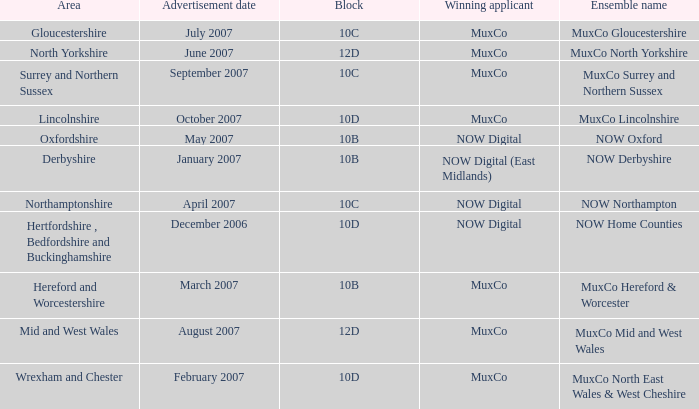Which Block does Northamptonshire Area have? 10C. Give me the full table as a dictionary. {'header': ['Area', 'Advertisement date', 'Block', 'Winning applicant', 'Ensemble name'], 'rows': [['Gloucestershire', 'July 2007', '10C', 'MuxCo', 'MuxCo Gloucestershire'], ['North Yorkshire', 'June 2007', '12D', 'MuxCo', 'MuxCo North Yorkshire'], ['Surrey and Northern Sussex', 'September 2007', '10C', 'MuxCo', 'MuxCo Surrey and Northern Sussex'], ['Lincolnshire', 'October 2007', '10D', 'MuxCo', 'MuxCo Lincolnshire'], ['Oxfordshire', 'May 2007', '10B', 'NOW Digital', 'NOW Oxford'], ['Derbyshire', 'January 2007', '10B', 'NOW Digital (East Midlands)', 'NOW Derbyshire'], ['Northamptonshire', 'April 2007', '10C', 'NOW Digital', 'NOW Northampton'], ['Hertfordshire , Bedfordshire and Buckinghamshire', 'December 2006', '10D', 'NOW Digital', 'NOW Home Counties'], ['Hereford and Worcestershire', 'March 2007', '10B', 'MuxCo', 'MuxCo Hereford & Worcester'], ['Mid and West Wales', 'August 2007', '12D', 'MuxCo', 'MuxCo Mid and West Wales'], ['Wrexham and Chester', 'February 2007', '10D', 'MuxCo', 'MuxCo North East Wales & West Cheshire']]} 